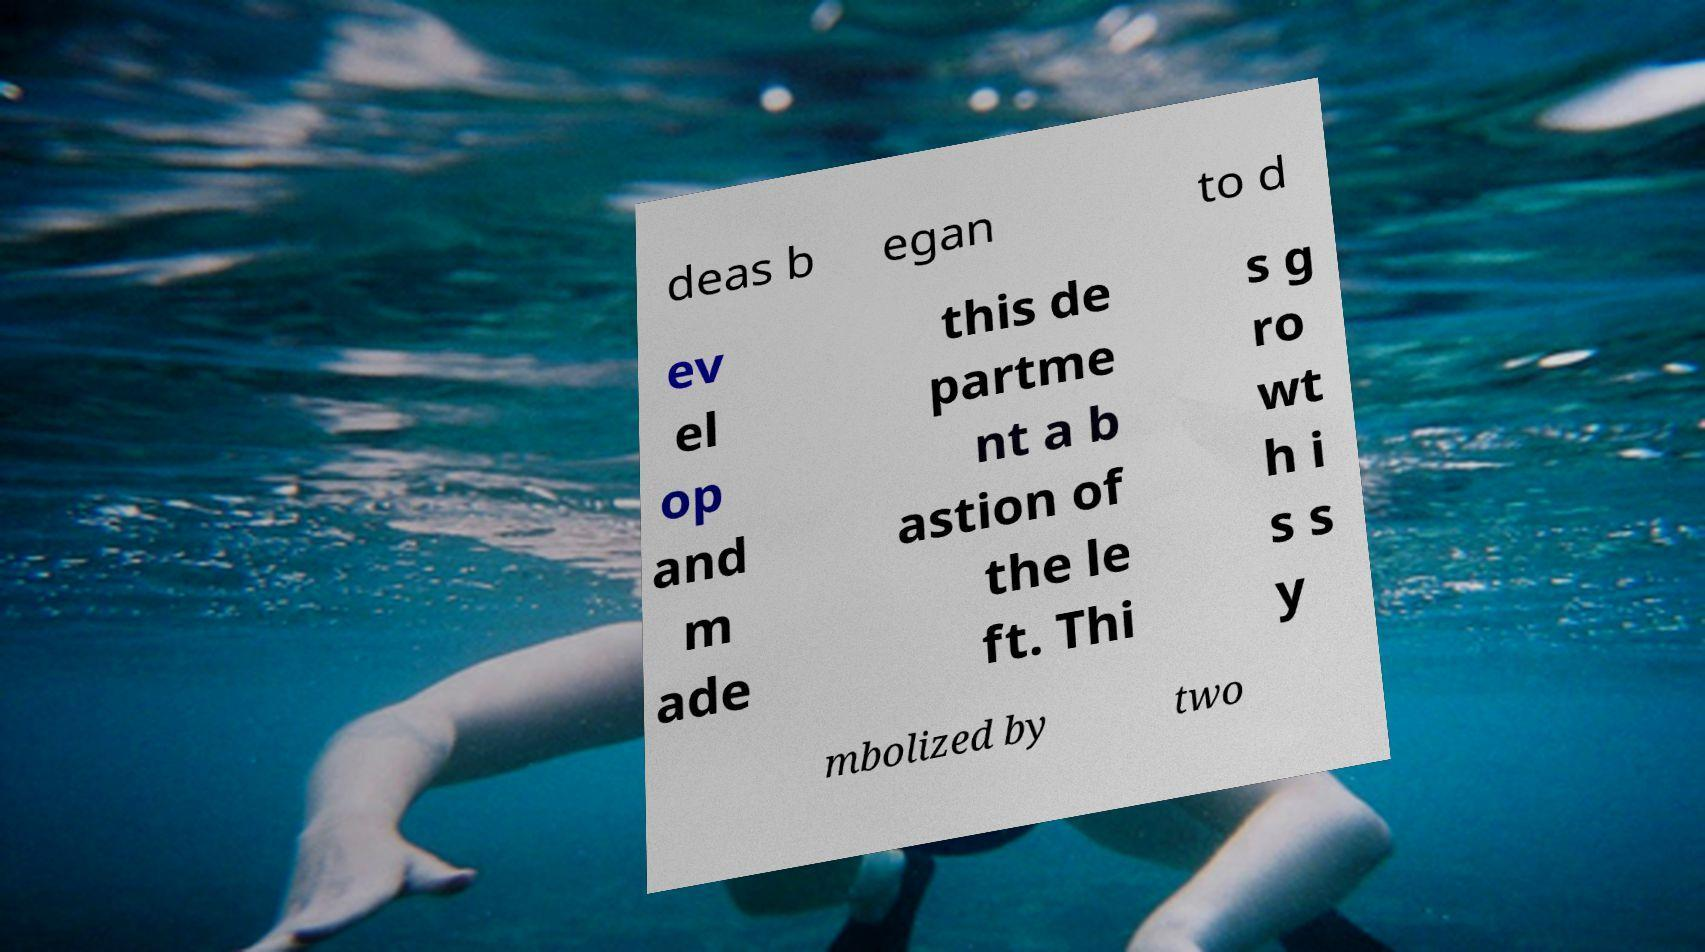Please read and relay the text visible in this image. What does it say? deas b egan to d ev el op and m ade this de partme nt a b astion of the le ft. Thi s g ro wt h i s s y mbolized by two 